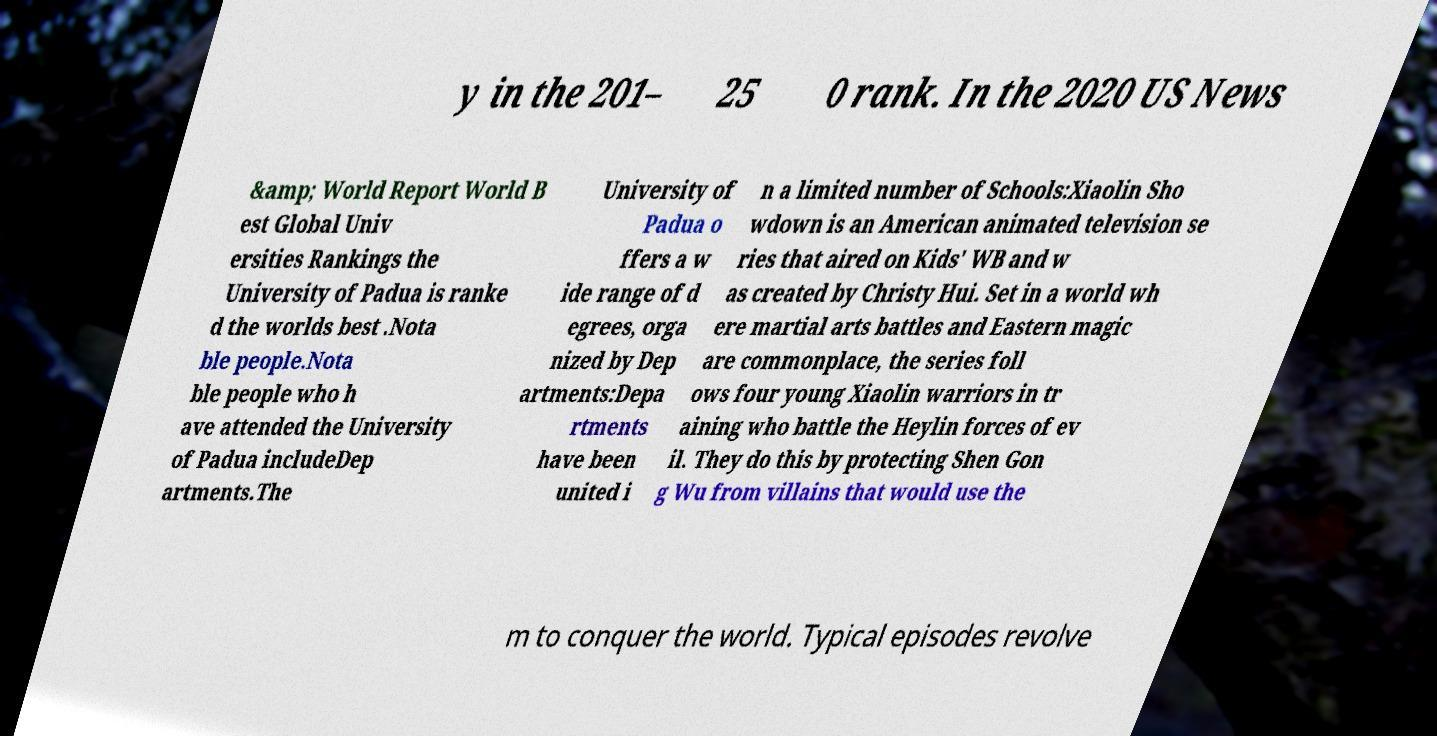Could you extract and type out the text from this image? y in the 201– 25 0 rank. In the 2020 US News &amp; World Report World B est Global Univ ersities Rankings the University of Padua is ranke d the worlds best .Nota ble people.Nota ble people who h ave attended the University of Padua includeDep artments.The University of Padua o ffers a w ide range of d egrees, orga nized by Dep artments:Depa rtments have been united i n a limited number of Schools:Xiaolin Sho wdown is an American animated television se ries that aired on Kids' WB and w as created by Christy Hui. Set in a world wh ere martial arts battles and Eastern magic are commonplace, the series foll ows four young Xiaolin warriors in tr aining who battle the Heylin forces of ev il. They do this by protecting Shen Gon g Wu from villains that would use the m to conquer the world. Typical episodes revolve 